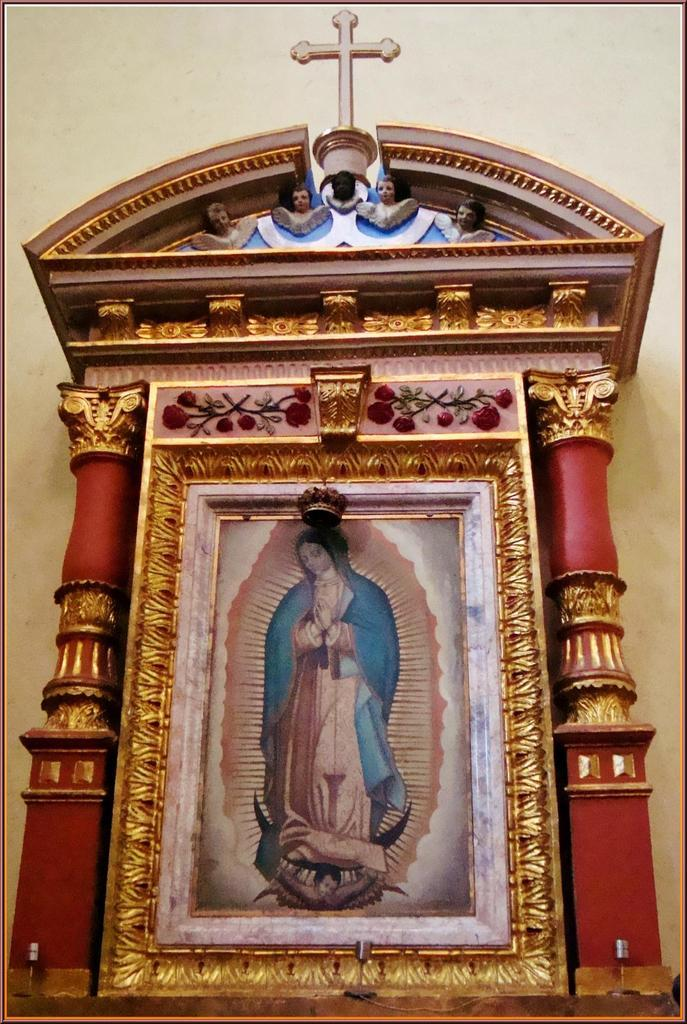What object is visible in the image that might hold a photograph? There is a photo frame in the image. What type of decoration can be seen on the wall in the image? There are wood carvings on the wall in the image. What type of tax is being discussed in the image? There is no mention of tax or any discussion in the image; it only features a photo frame and wood carvings on the wall. 